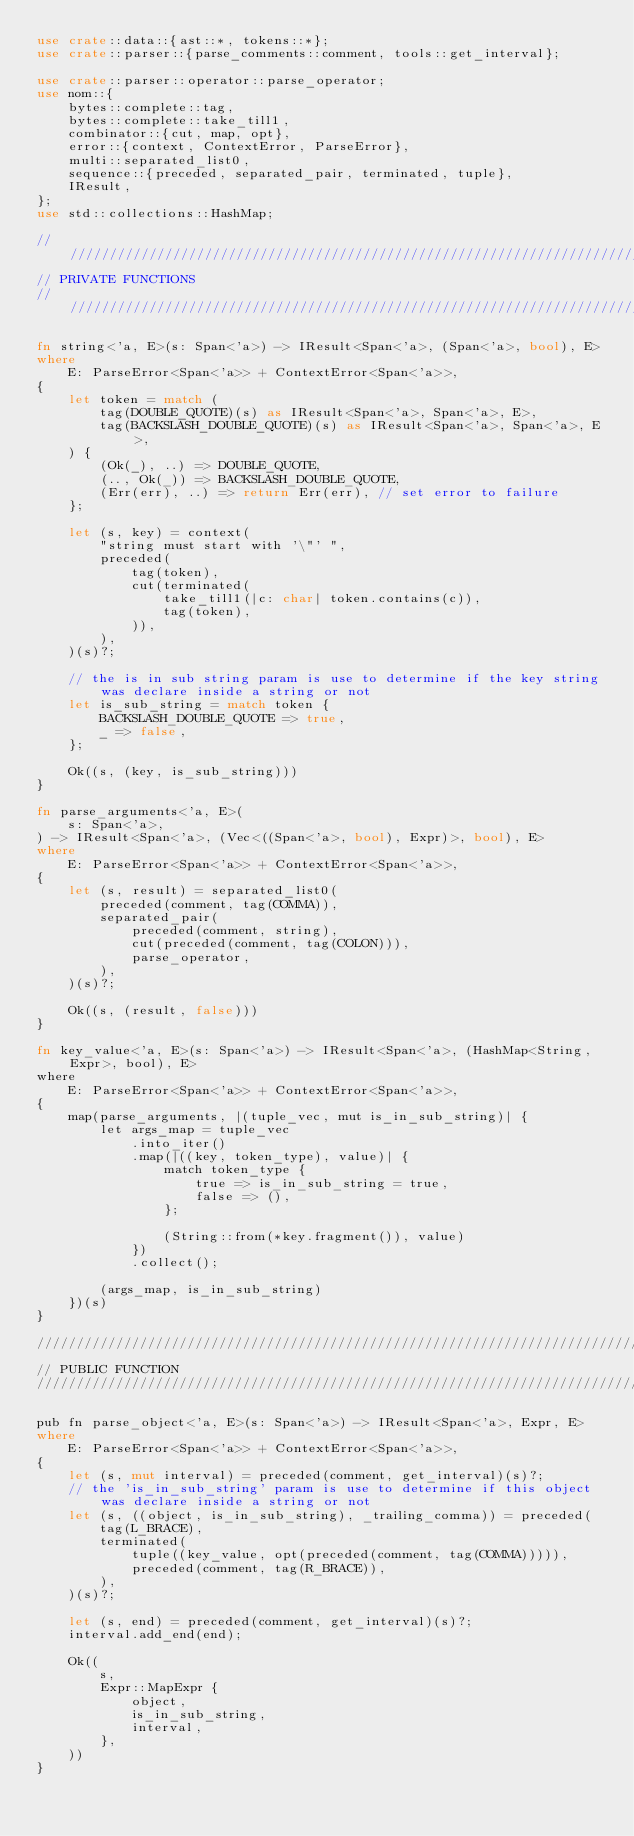<code> <loc_0><loc_0><loc_500><loc_500><_Rust_>use crate::data::{ast::*, tokens::*};
use crate::parser::{parse_comments::comment, tools::get_interval};

use crate::parser::operator::parse_operator;
use nom::{
    bytes::complete::tag,
    bytes::complete::take_till1,
    combinator::{cut, map, opt},
    error::{context, ContextError, ParseError},
    multi::separated_list0,
    sequence::{preceded, separated_pair, terminated, tuple},
    IResult,
};
use std::collections::HashMap;

////////////////////////////////////////////////////////////////////////////////
// PRIVATE FUNCTIONS
////////////////////////////////////////////////////////////////////////////////

fn string<'a, E>(s: Span<'a>) -> IResult<Span<'a>, (Span<'a>, bool), E>
where
    E: ParseError<Span<'a>> + ContextError<Span<'a>>,
{
    let token = match (
        tag(DOUBLE_QUOTE)(s) as IResult<Span<'a>, Span<'a>, E>,
        tag(BACKSLASH_DOUBLE_QUOTE)(s) as IResult<Span<'a>, Span<'a>, E>,
    ) {
        (Ok(_), ..) => DOUBLE_QUOTE,
        (.., Ok(_)) => BACKSLASH_DOUBLE_QUOTE,
        (Err(err), ..) => return Err(err), // set error to failure
    };

    let (s, key) = context(
        "string must start with '\"' ",
        preceded(
            tag(token),
            cut(terminated(
                take_till1(|c: char| token.contains(c)),
                tag(token),
            )),
        ),
    )(s)?;

    // the is in sub string param is use to determine if the key string was declare inside a string or not
    let is_sub_string = match token {
        BACKSLASH_DOUBLE_QUOTE => true,
        _ => false,
    };

    Ok((s, (key, is_sub_string)))
}

fn parse_arguments<'a, E>(
    s: Span<'a>,
) -> IResult<Span<'a>, (Vec<((Span<'a>, bool), Expr)>, bool), E>
where
    E: ParseError<Span<'a>> + ContextError<Span<'a>>,
{
    let (s, result) = separated_list0(
        preceded(comment, tag(COMMA)),
        separated_pair(
            preceded(comment, string),
            cut(preceded(comment, tag(COLON))),
            parse_operator,
        ),
    )(s)?;

    Ok((s, (result, false)))
}

fn key_value<'a, E>(s: Span<'a>) -> IResult<Span<'a>, (HashMap<String, Expr>, bool), E>
where
    E: ParseError<Span<'a>> + ContextError<Span<'a>>,
{
    map(parse_arguments, |(tuple_vec, mut is_in_sub_string)| {
        let args_map = tuple_vec
            .into_iter()
            .map(|((key, token_type), value)| {
                match token_type {
                    true => is_in_sub_string = true,
                    false => (),
                };

                (String::from(*key.fragment()), value)
            })
            .collect();

        (args_map, is_in_sub_string)
    })(s)
}

////////////////////////////////////////////////////////////////////////////////
// PUBLIC FUNCTION
////////////////////////////////////////////////////////////////////////////////

pub fn parse_object<'a, E>(s: Span<'a>) -> IResult<Span<'a>, Expr, E>
where
    E: ParseError<Span<'a>> + ContextError<Span<'a>>,
{
    let (s, mut interval) = preceded(comment, get_interval)(s)?;
    // the 'is_in_sub_string' param is use to determine if this object was declare inside a string or not
    let (s, ((object, is_in_sub_string), _trailing_comma)) = preceded(
        tag(L_BRACE),
        terminated(
            tuple((key_value, opt(preceded(comment, tag(COMMA))))),
            preceded(comment, tag(R_BRACE)),
        ),
    )(s)?;

    let (s, end) = preceded(comment, get_interval)(s)?;
    interval.add_end(end);

    Ok((
        s,
        Expr::MapExpr {
            object,
            is_in_sub_string,
            interval,
        },
    ))
}
</code> 